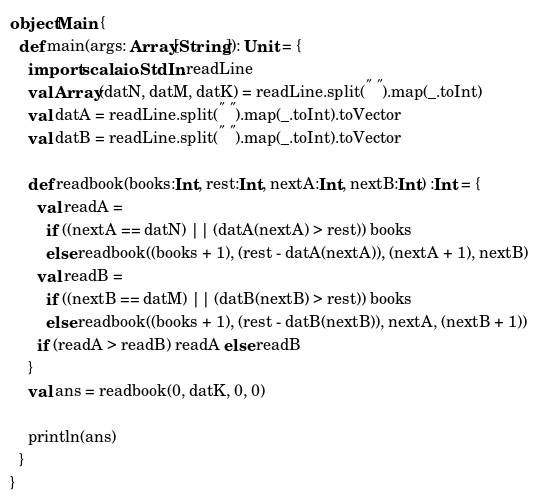<code> <loc_0><loc_0><loc_500><loc_500><_Scala_>object Main {
  def main(args: Array[String]): Unit = {
    import scala.io.StdIn.readLine
    val Array(datN, datM, datK) = readLine.split(" ").map(_.toInt)
    val datA = readLine.split(" ").map(_.toInt).toVector
    val datB = readLine.split(" ").map(_.toInt).toVector

    def readbook(books:Int, rest:Int, nextA:Int, nextB:Int) :Int = {
      val readA =
        if ((nextA == datN) || (datA(nextA) > rest)) books
        else readbook((books + 1), (rest - datA(nextA)), (nextA + 1), nextB)
      val readB =
        if ((nextB == datM) || (datB(nextB) > rest)) books
        else readbook((books + 1), (rest - datB(nextB)), nextA, (nextB + 1))
      if (readA > readB) readA else readB
    }
    val ans = readbook(0, datK, 0, 0)

    println(ans)
  }
}
</code> 